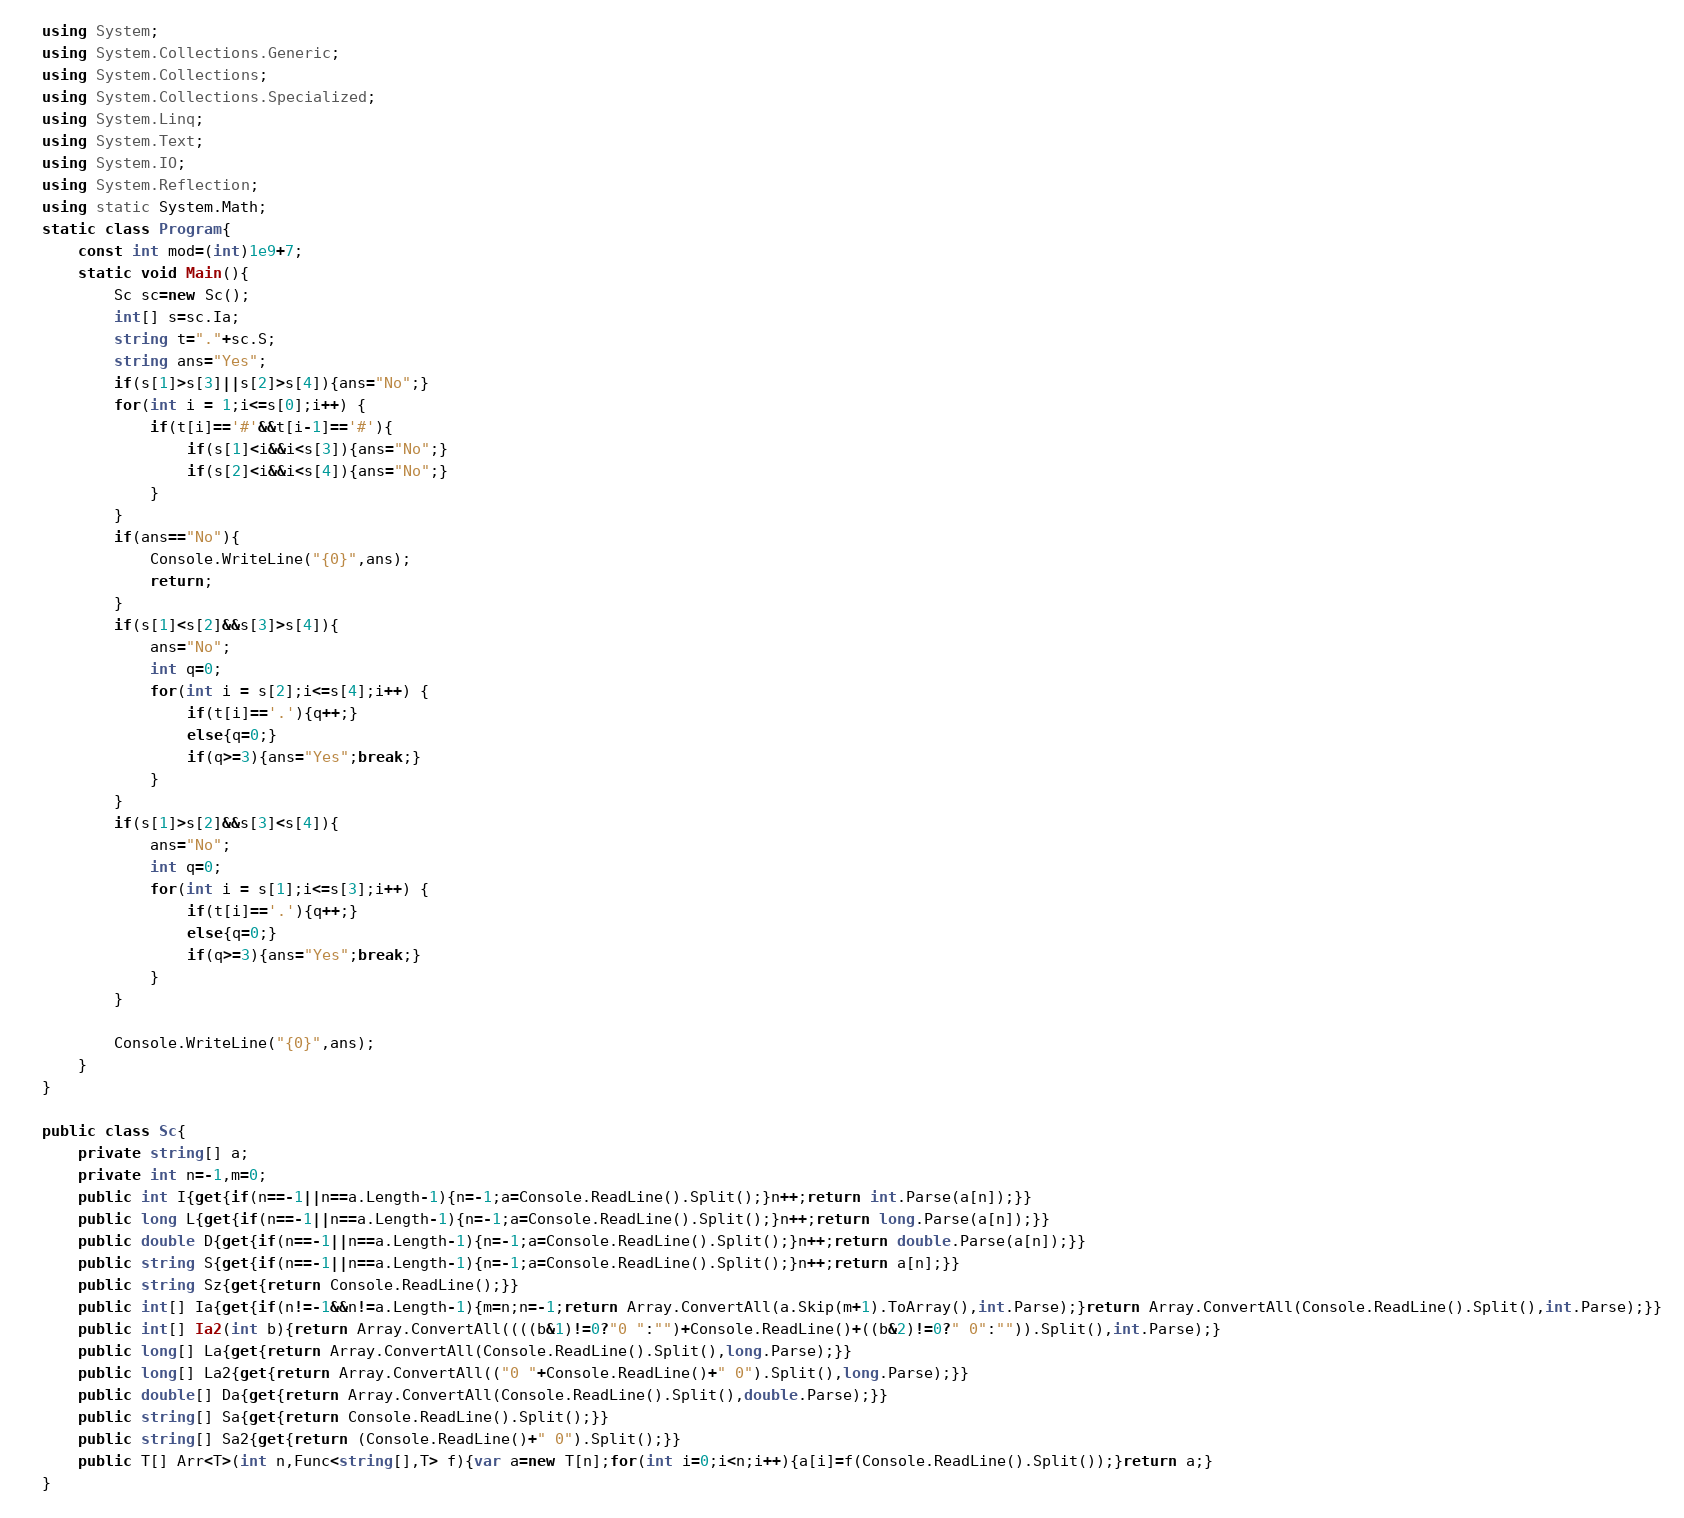Convert code to text. <code><loc_0><loc_0><loc_500><loc_500><_C#_>using System;
using System.Collections.Generic;
using System.Collections;
using System.Collections.Specialized;
using System.Linq;
using System.Text;
using System.IO;
using System.Reflection;
using static System.Math;
static class Program{
	const int mod=(int)1e9+7;
	static void Main(){
		Sc sc=new Sc();
		int[] s=sc.Ia;
		string t="."+sc.S;
		string ans="Yes";
		if(s[1]>s[3]||s[2]>s[4]){ans="No";}
		for(int i = 1;i<=s[0];i++) {
			if(t[i]=='#'&&t[i-1]=='#'){
				if(s[1]<i&&i<s[3]){ans="No";}
				if(s[2]<i&&i<s[4]){ans="No";}
			}
		}
		if(ans=="No"){
			Console.WriteLine("{0}",ans);
			return;
		}
		if(s[1]<s[2]&&s[3]>s[4]){
			ans="No";
			int q=0;
			for(int i = s[2];i<=s[4];i++) {
				if(t[i]=='.'){q++;}
				else{q=0;}
				if(q>=3){ans="Yes";break;}
			}
		}
		if(s[1]>s[2]&&s[3]<s[4]){
			ans="No";
			int q=0;
			for(int i = s[1];i<=s[3];i++) {
				if(t[i]=='.'){q++;}
				else{q=0;}
				if(q>=3){ans="Yes";break;}
			}
		}

		Console.WriteLine("{0}",ans);
	}
}

public class Sc{
	private string[] a;
	private int n=-1,m=0;
	public int I{get{if(n==-1||n==a.Length-1){n=-1;a=Console.ReadLine().Split();}n++;return int.Parse(a[n]);}}
	public long L{get{if(n==-1||n==a.Length-1){n=-1;a=Console.ReadLine().Split();}n++;return long.Parse(a[n]);}}
	public double D{get{if(n==-1||n==a.Length-1){n=-1;a=Console.ReadLine().Split();}n++;return double.Parse(a[n]);}}
	public string S{get{if(n==-1||n==a.Length-1){n=-1;a=Console.ReadLine().Split();}n++;return a[n];}}
	public string Sz{get{return Console.ReadLine();}}
	public int[] Ia{get{if(n!=-1&&n!=a.Length-1){m=n;n=-1;return Array.ConvertAll(a.Skip(m+1).ToArray(),int.Parse);}return Array.ConvertAll(Console.ReadLine().Split(),int.Parse);}}
	public int[] Ia2(int b){return Array.ConvertAll((((b&1)!=0?"0 ":"")+Console.ReadLine()+((b&2)!=0?" 0":"")).Split(),int.Parse);}
	public long[] La{get{return Array.ConvertAll(Console.ReadLine().Split(),long.Parse);}}
	public long[] La2{get{return Array.ConvertAll(("0 "+Console.ReadLine()+" 0").Split(),long.Parse);}}
	public double[] Da{get{return Array.ConvertAll(Console.ReadLine().Split(),double.Parse);}}
	public string[] Sa{get{return Console.ReadLine().Split();}}
	public string[] Sa2{get{return (Console.ReadLine()+" 0").Split();}}
	public T[] Arr<T>(int n,Func<string[],T> f){var a=new T[n];for(int i=0;i<n;i++){a[i]=f(Console.ReadLine().Split());}return a;}
}</code> 